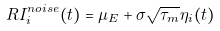Convert formula to latex. <formula><loc_0><loc_0><loc_500><loc_500>R I _ { i } ^ { n o i s e } ( t ) = \mu _ { E } + \sigma \sqrt { \tau _ { m } } \eta _ { i } ( t )</formula> 